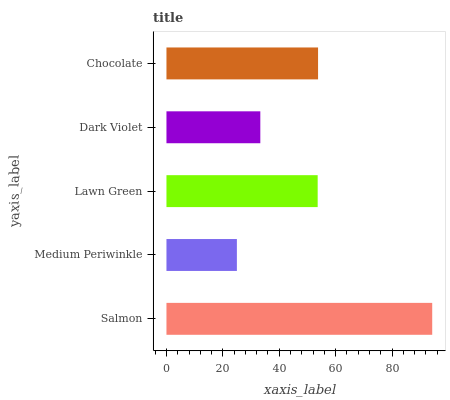Is Medium Periwinkle the minimum?
Answer yes or no. Yes. Is Salmon the maximum?
Answer yes or no. Yes. Is Lawn Green the minimum?
Answer yes or no. No. Is Lawn Green the maximum?
Answer yes or no. No. Is Lawn Green greater than Medium Periwinkle?
Answer yes or no. Yes. Is Medium Periwinkle less than Lawn Green?
Answer yes or no. Yes. Is Medium Periwinkle greater than Lawn Green?
Answer yes or no. No. Is Lawn Green less than Medium Periwinkle?
Answer yes or no. No. Is Lawn Green the high median?
Answer yes or no. Yes. Is Lawn Green the low median?
Answer yes or no. Yes. Is Medium Periwinkle the high median?
Answer yes or no. No. Is Chocolate the low median?
Answer yes or no. No. 